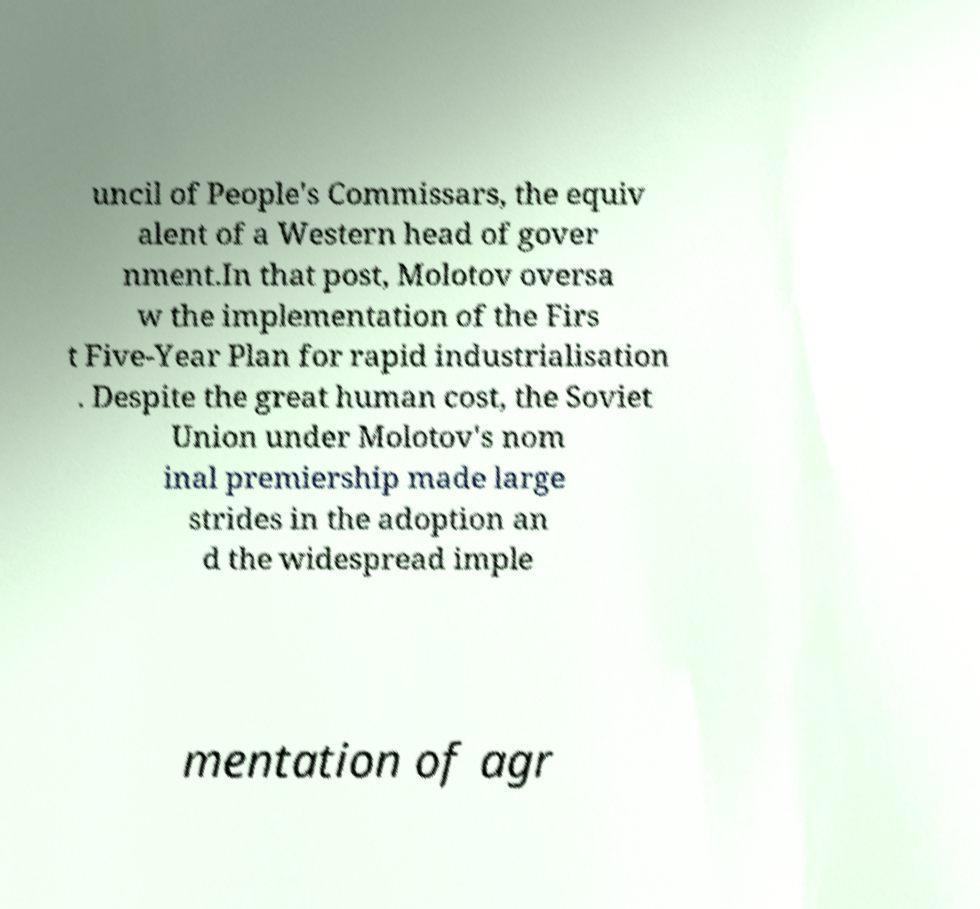Could you extract and type out the text from this image? uncil of People's Commissars, the equiv alent of a Western head of gover nment.In that post, Molotov oversa w the implementation of the Firs t Five-Year Plan for rapid industrialisation . Despite the great human cost, the Soviet Union under Molotov's nom inal premiership made large strides in the adoption an d the widespread imple mentation of agr 